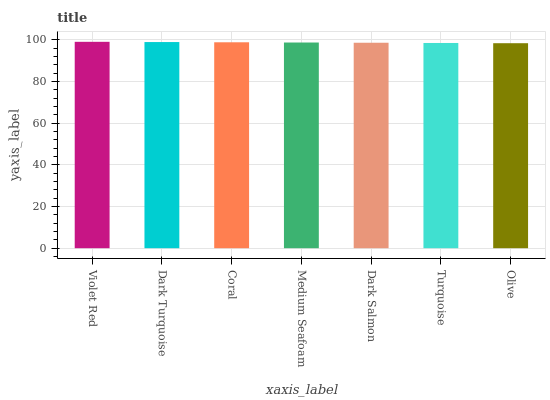Is Olive the minimum?
Answer yes or no. Yes. Is Violet Red the maximum?
Answer yes or no. Yes. Is Dark Turquoise the minimum?
Answer yes or no. No. Is Dark Turquoise the maximum?
Answer yes or no. No. Is Violet Red greater than Dark Turquoise?
Answer yes or no. Yes. Is Dark Turquoise less than Violet Red?
Answer yes or no. Yes. Is Dark Turquoise greater than Violet Red?
Answer yes or no. No. Is Violet Red less than Dark Turquoise?
Answer yes or no. No. Is Medium Seafoam the high median?
Answer yes or no. Yes. Is Medium Seafoam the low median?
Answer yes or no. Yes. Is Coral the high median?
Answer yes or no. No. Is Violet Red the low median?
Answer yes or no. No. 